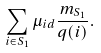<formula> <loc_0><loc_0><loc_500><loc_500>\sum _ { i \in S _ { 1 } } \mu _ { i d } \frac { m _ { S _ { 1 } } } { q ( i ) } .</formula> 